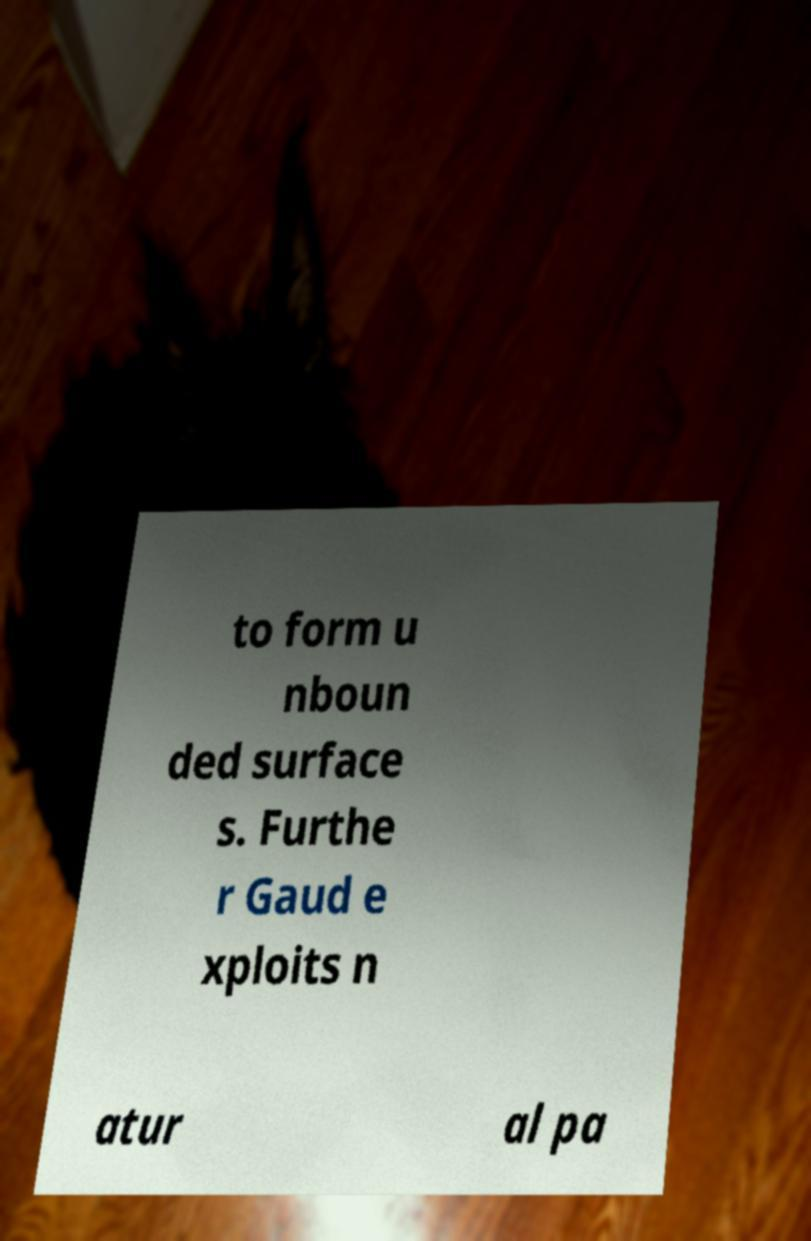I need the written content from this picture converted into text. Can you do that? to form u nboun ded surface s. Furthe r Gaud e xploits n atur al pa 